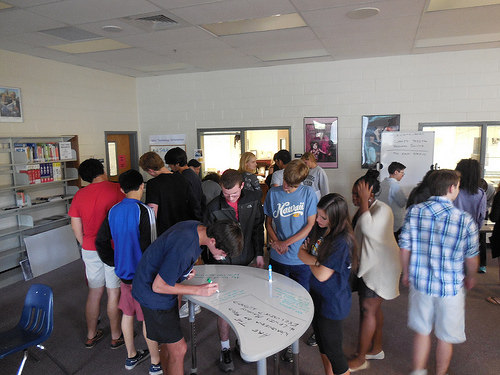<image>
Can you confirm if the picture is to the right of the door? Yes. From this viewpoint, the picture is positioned to the right side relative to the door. 